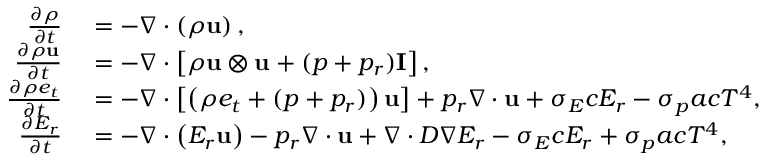Convert formula to latex. <formula><loc_0><loc_0><loc_500><loc_500>\begin{array} { r l } { \frac { \partial \rho } { \partial t } } & = - \nabla \cdot \left ( \rho u \right ) , } \\ { \frac { \partial \rho u } { \partial t } } & = - \nabla \cdot \left [ \rho u \otimes u + ( p + { p _ { r } } ) I \right ] , } \\ { \frac { \partial \rho e _ { t } } { \partial t } } & = - \nabla \cdot \left [ \left ( \rho e _ { t } + ( p + { p _ { r } } ) \right ) u \right ] + { p _ { r } \nabla \cdot u } + { \sigma _ { E } c E _ { r } } - { \sigma _ { p } a c T ^ { 4 } } , } \\ { \frac { \partial E _ { r } } { \partial t } } & = - \nabla \cdot \left ( E _ { r } u \right ) - { p _ { r } \nabla \cdot u } + \nabla \cdot D \nabla E _ { r } - { \sigma _ { E } c E _ { r } } + { \sigma _ { p } a c T ^ { 4 } } , } \end{array}</formula> 